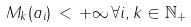<formula> <loc_0><loc_0><loc_500><loc_500>M _ { k } ( a _ { i } ) \, < \, + \infty \, \forall i , k \in { \mathbb { N } } _ { + }</formula> 